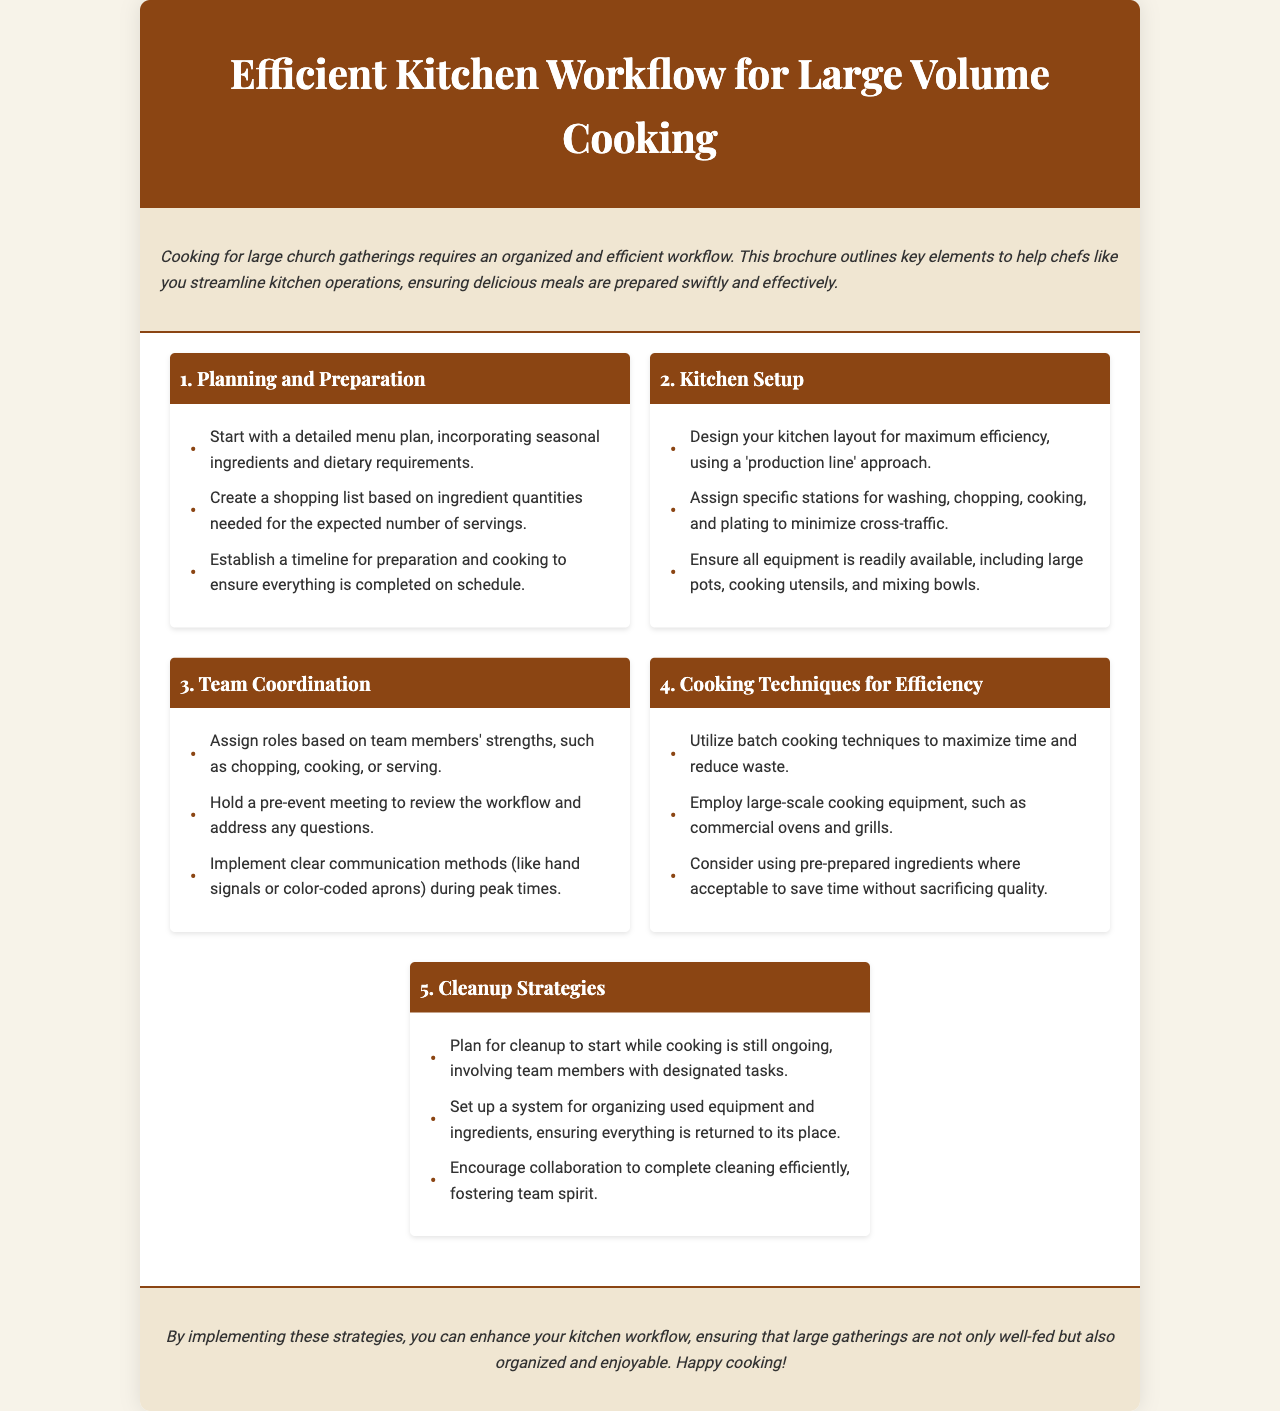what is the title of the brochure? The title of the brochure is specified in the header section of the document.
Answer: Efficient Kitchen Workflow for Large Volume Cooking what is the main goal of the brochure? The goal is mentioned in the introduction section to help chefs streamline kitchen operations.
Answer: Streamline kitchen operations how many sections are included in the content? The number of sections can be counted from the document content, excluding the introduction and conclusion.
Answer: Five what is the first step listed under Planning and Preparation? The first step is outlined in the first section of the document under Planning and Preparation.
Answer: Start with a detailed menu plan what cooking technique is recommended to maximize time? The appropriate technique is mentioned in the Cooking Techniques for Efficiency section.
Answer: Batch cooking techniques how should roles be assigned in team coordination? This is detailed in the Team Coordination section of the document.
Answer: Based on team members' strengths what is suggested to encourage team spirit during cleanup? This is found in the Cleanup Strategies section of the document.
Answer: Encourage collaboration what is included in the introduction of the brochure? The introduction generally outlines the purpose and importance of the brochure.
Answer: Organized and efficient workflow how does the brochure suggest handling cleaning? The method for cleaning is explained in the Cleanup Strategies section of the document.
Answer: Plan for cleanup to start while cooking 